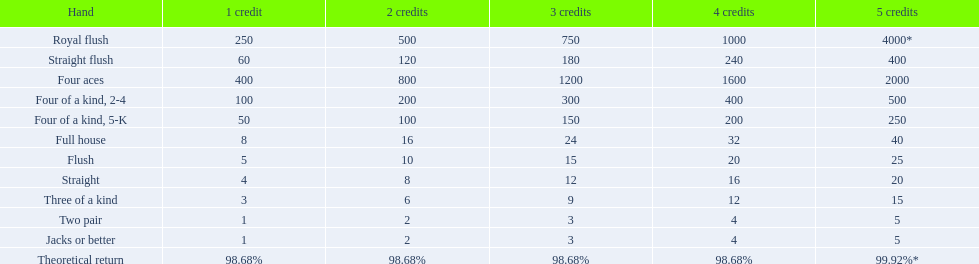In the 5-credit section, what are the values? 4000*, 400, 2000, 500, 250, 40, 25, 20, 15, 5, 5. Which one is associated with a four of a kind? 500, 250. Can you parse all the data within this table? {'header': ['Hand', '1 credit', '2 credits', '3 credits', '4 credits', '5 credits'], 'rows': [['Royal flush', '250', '500', '750', '1000', '4000*'], ['Straight flush', '60', '120', '180', '240', '400'], ['Four aces', '400', '800', '1200', '1600', '2000'], ['Four of a kind, 2-4', '100', '200', '300', '400', '500'], ['Four of a kind, 5-K', '50', '100', '150', '200', '250'], ['Full house', '8', '16', '24', '32', '40'], ['Flush', '5', '10', '15', '20', '25'], ['Straight', '4', '8', '12', '16', '20'], ['Three of a kind', '3', '6', '9', '12', '15'], ['Two pair', '1', '2', '3', '4', '5'], ['Jacks or better', '1', '2', '3', '4', '5'], ['Theoretical return', '98.68%', '98.68%', '98.68%', '98.68%', '99.92%*']]} Which value is higher? 500. For which hand is this applicable? Four of a kind, 2-4. 